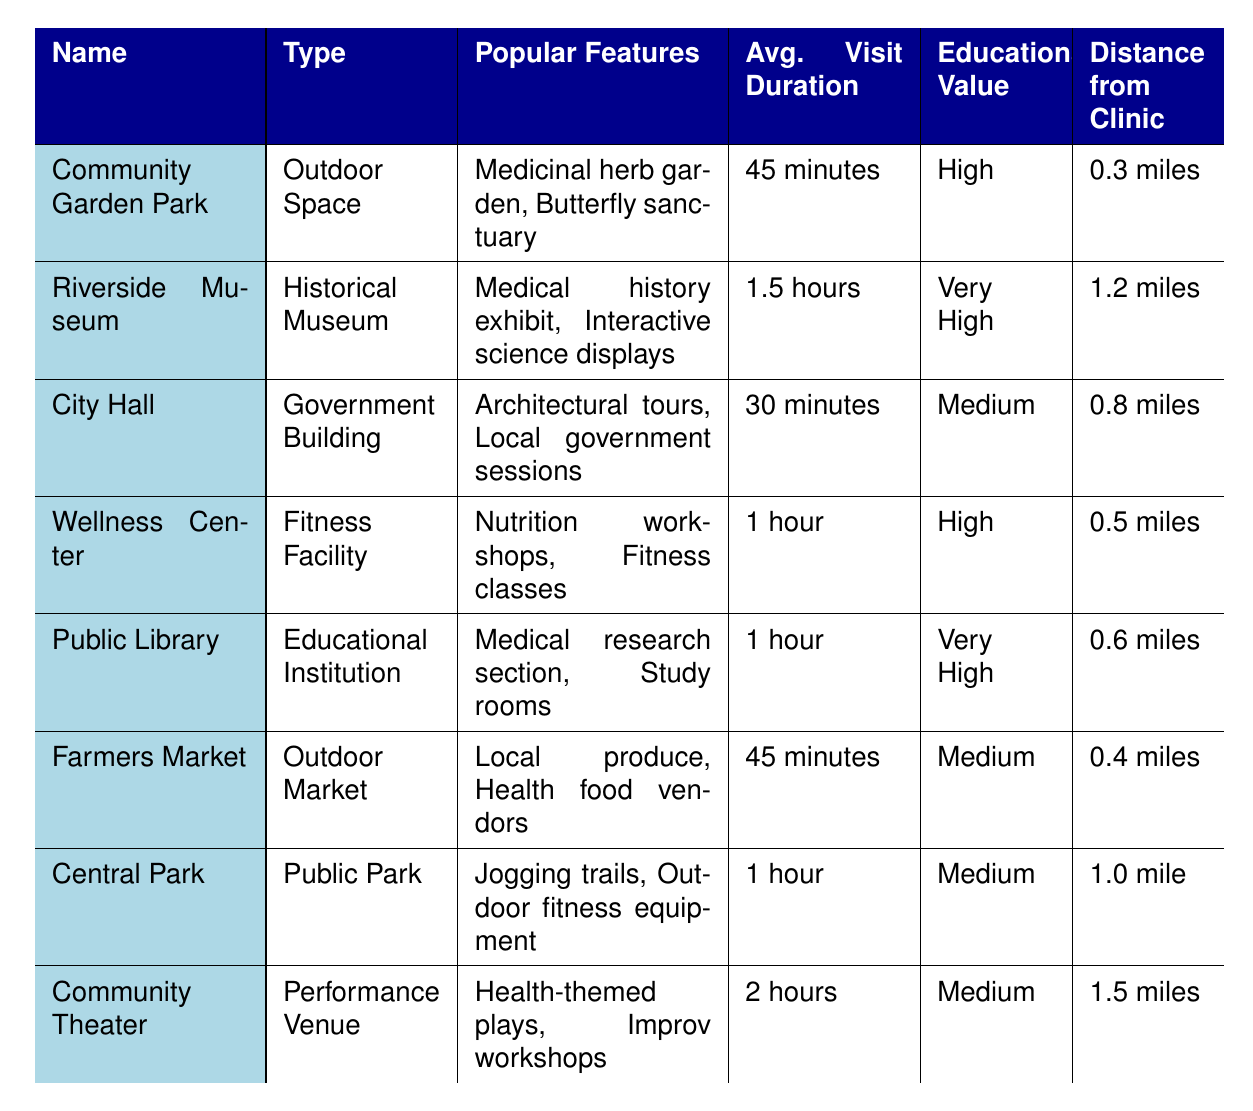What is the most educationally valuable local attraction? The table shows that both the Riverside Museum and the Public Library have an educational value categorized as "Very High." Therefore, either of these could be considered the most educationally valuable local attraction.
Answer: Riverside Museum or Public Library Which attraction is the closest to the clinic? The Community Garden Park is listed first in the table and has a distance of 0.3 miles from the clinic, which is the shortest distance in the provided data.
Answer: Community Garden Park How long does it take on average to visit the Riverside Museum? According to the table, the average visit duration for the Riverside Museum is 1.5 hours. This information is directly stated in the table.
Answer: 1.5 hours Is the Farmers Market more educationally valuable than the Central Park? The Farmers Market has a medium educational value, while Central Park also has a medium educational value. Therefore, they are equally valuable in terms of education.
Answer: No What is the total average visit duration for the top two most time-consuming attractions? The two attractions with the longest visit durations are Community Theater (2 hours) and Riverside Museum (1.5 hours). Adding these together gives a total visit duration of 3.5 hours.
Answer: 3.5 hours Which type of attraction has an average visit duration longer than 1 hour? The attractions that have an average visit duration longer than 1 hour in the table are the Riverside Museum (1.5 hours) and Community Theater (2 hours). Both fit this criterion.
Answer: Riverside Museum and Community Theater How far is the Wellness Center from the clinic? The table states that the distance from the clinic to the Wellness Center is 0.5 miles, so this is a direct reference from the data.
Answer: 0.5 miles Which local attraction has the longest average visit duration and what is that duration? The Community Theater has the longest average visit duration of 2 hours, making it the attraction that takes the longest to visit. This is straightforward from the table.
Answer: 2 hours Is there any outdoor space listed in the attractions? Yes, the Community Garden Park is identified as an outdoor space in the table. This directly addresses the query about the existence of outdoor spaces in the list.
Answer: Yes What are the educational values of the two attractions located furthest from the clinic? The two attractions that are the furthest from the clinic are the Community Theater (1.5 miles) and the Riverside Museum (1.2 miles). Their educational values are both "Medium" for the Community Theater and "Very High" for the Riverside Museum.
Answer: Medium and Very High 